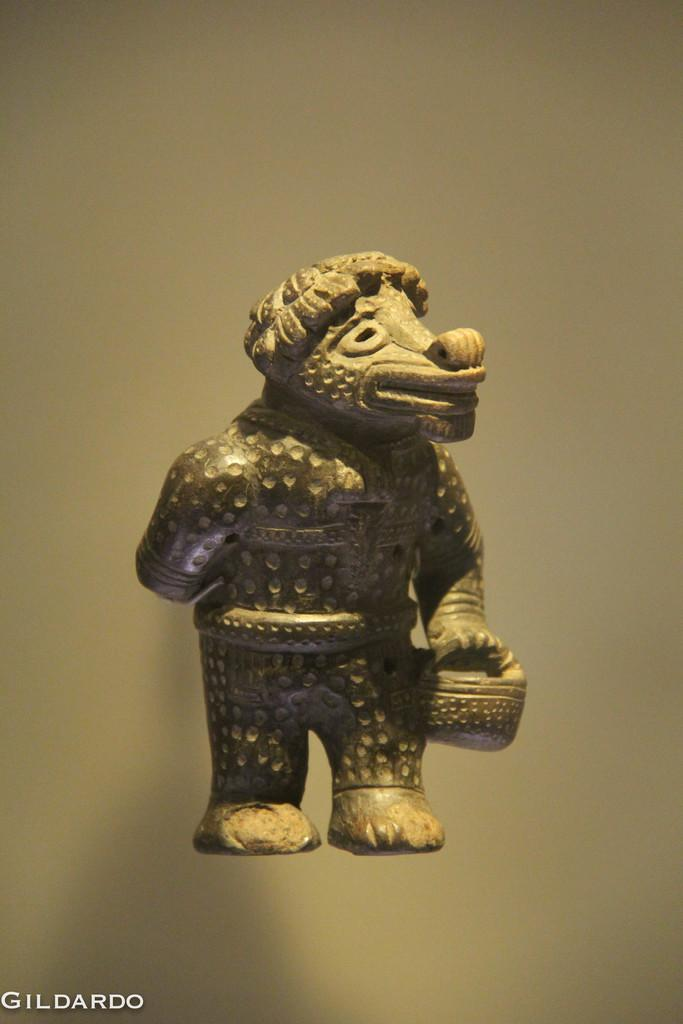What is the main subject of the image? There is a statue in the image. How would you describe the background of the image? The background of the image is blurry. Is there any text present in the image? Yes, there is text on the bottom left of the image. How many books are stacked on top of the statue in the image? There are no books present in the image; it features a statue with a blurry background and text on the bottom left. 